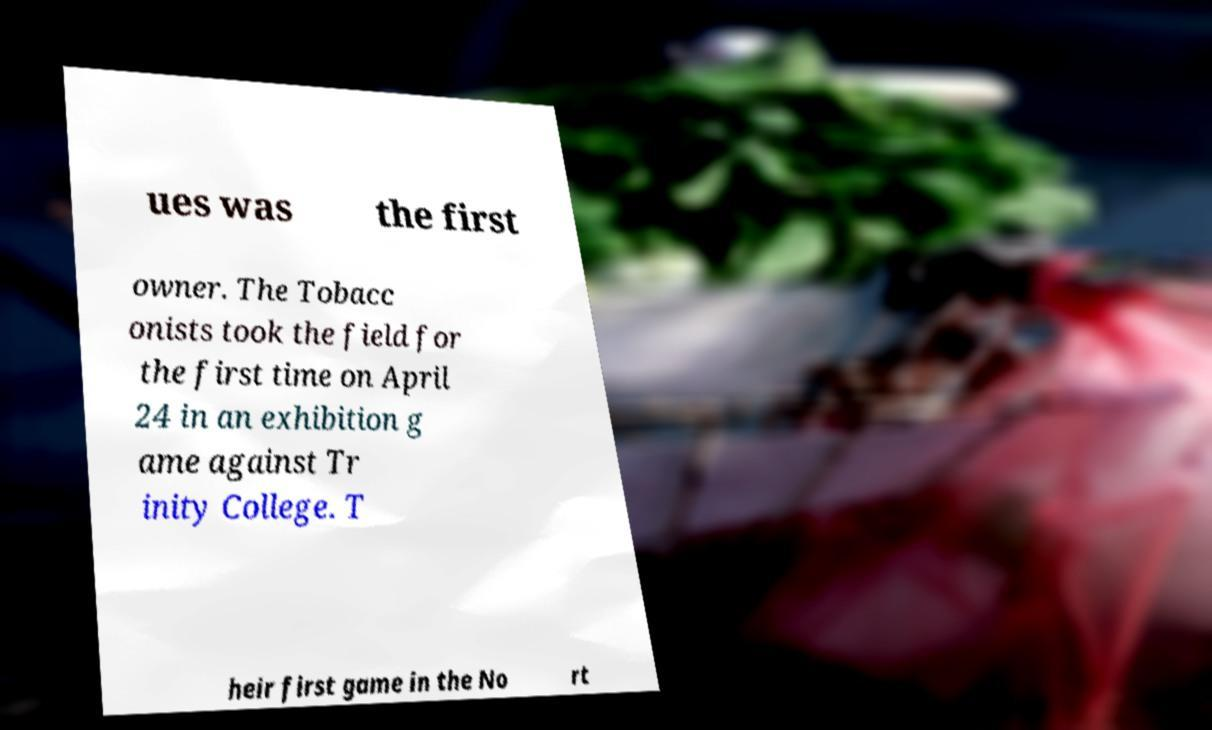Please identify and transcribe the text found in this image. ues was the first owner. The Tobacc onists took the field for the first time on April 24 in an exhibition g ame against Tr inity College. T heir first game in the No rt 